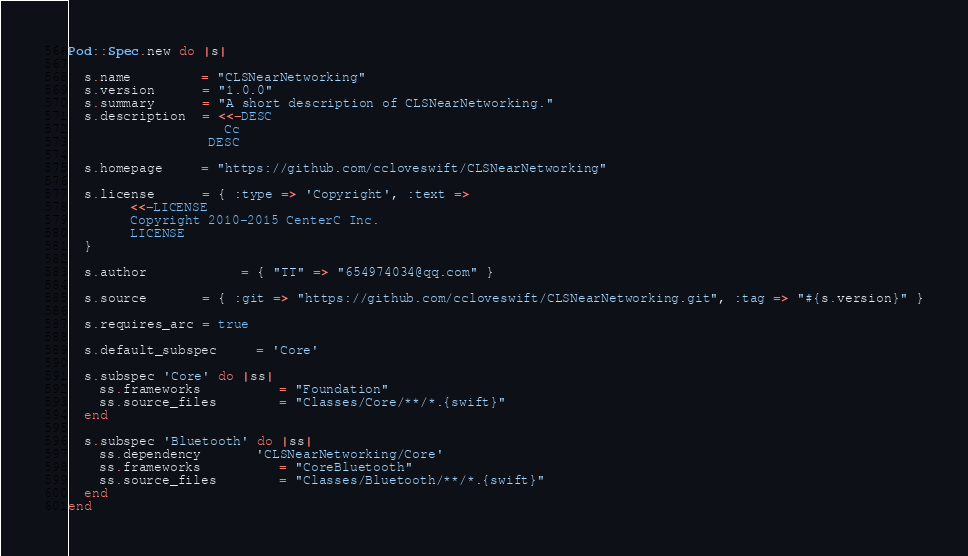<code> <loc_0><loc_0><loc_500><loc_500><_Ruby_>Pod::Spec.new do |s|

  s.name         = "CLSNearNetworking"
  s.version      = "1.0.0"
  s.summary      = "A short description of CLSNearNetworking."
  s.description  = <<-DESC
                    Cc
                  DESC

  s.homepage     = "https://github.com/ccloveswift/CLSNearNetworking"
  
  s.license      = { :type => 'Copyright', :text =>
        <<-LICENSE
        Copyright 2010-2015 CenterC Inc.
        LICENSE
  }
  
  s.author            = { "TT" => "654974034@qq.com" }

  s.source       = { :git => "https://github.com/ccloveswift/CLSNearNetworking.git", :tag => "#{s.version}" }

  s.requires_arc = true

  s.default_subspec     = 'Core'

  s.subspec 'Core' do |ss|
    ss.frameworks          = "Foundation"
    ss.source_files        = "Classes/Core/**/*.{swift}"
  end

  s.subspec 'Bluetooth' do |ss|
    ss.dependency       'CLSNearNetworking/Core'
    ss.frameworks          = "CoreBluetooth"
    ss.source_files        = "Classes/Bluetooth/**/*.{swift}"
  end
end
</code> 